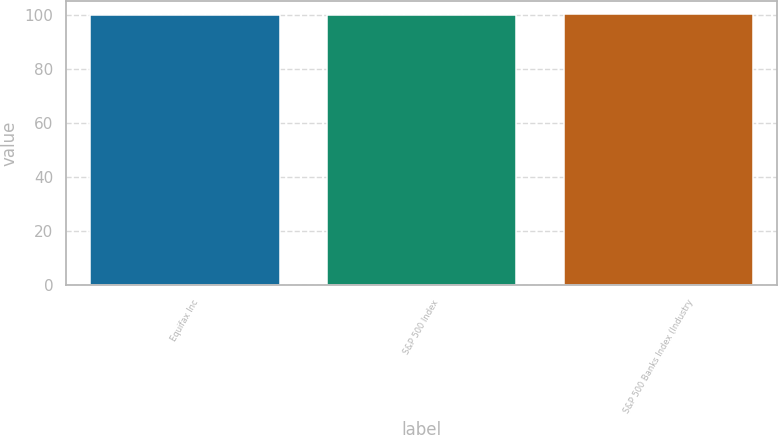Convert chart. <chart><loc_0><loc_0><loc_500><loc_500><bar_chart><fcel>Equifax Inc<fcel>S&P 500 Index<fcel>S&P 500 Banks Index (Industry<nl><fcel>100<fcel>100.1<fcel>100.2<nl></chart> 